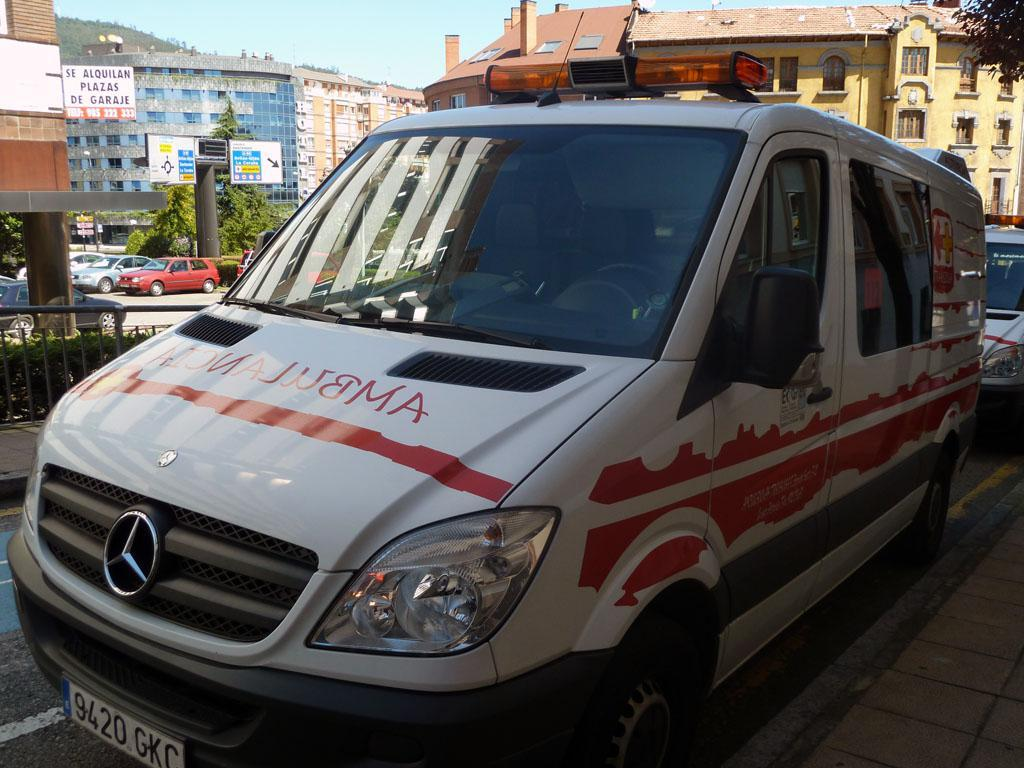<image>
Describe the image concisely. Ambulance type van from mercedes benz that has a license plate which says: 9420 GKC. 